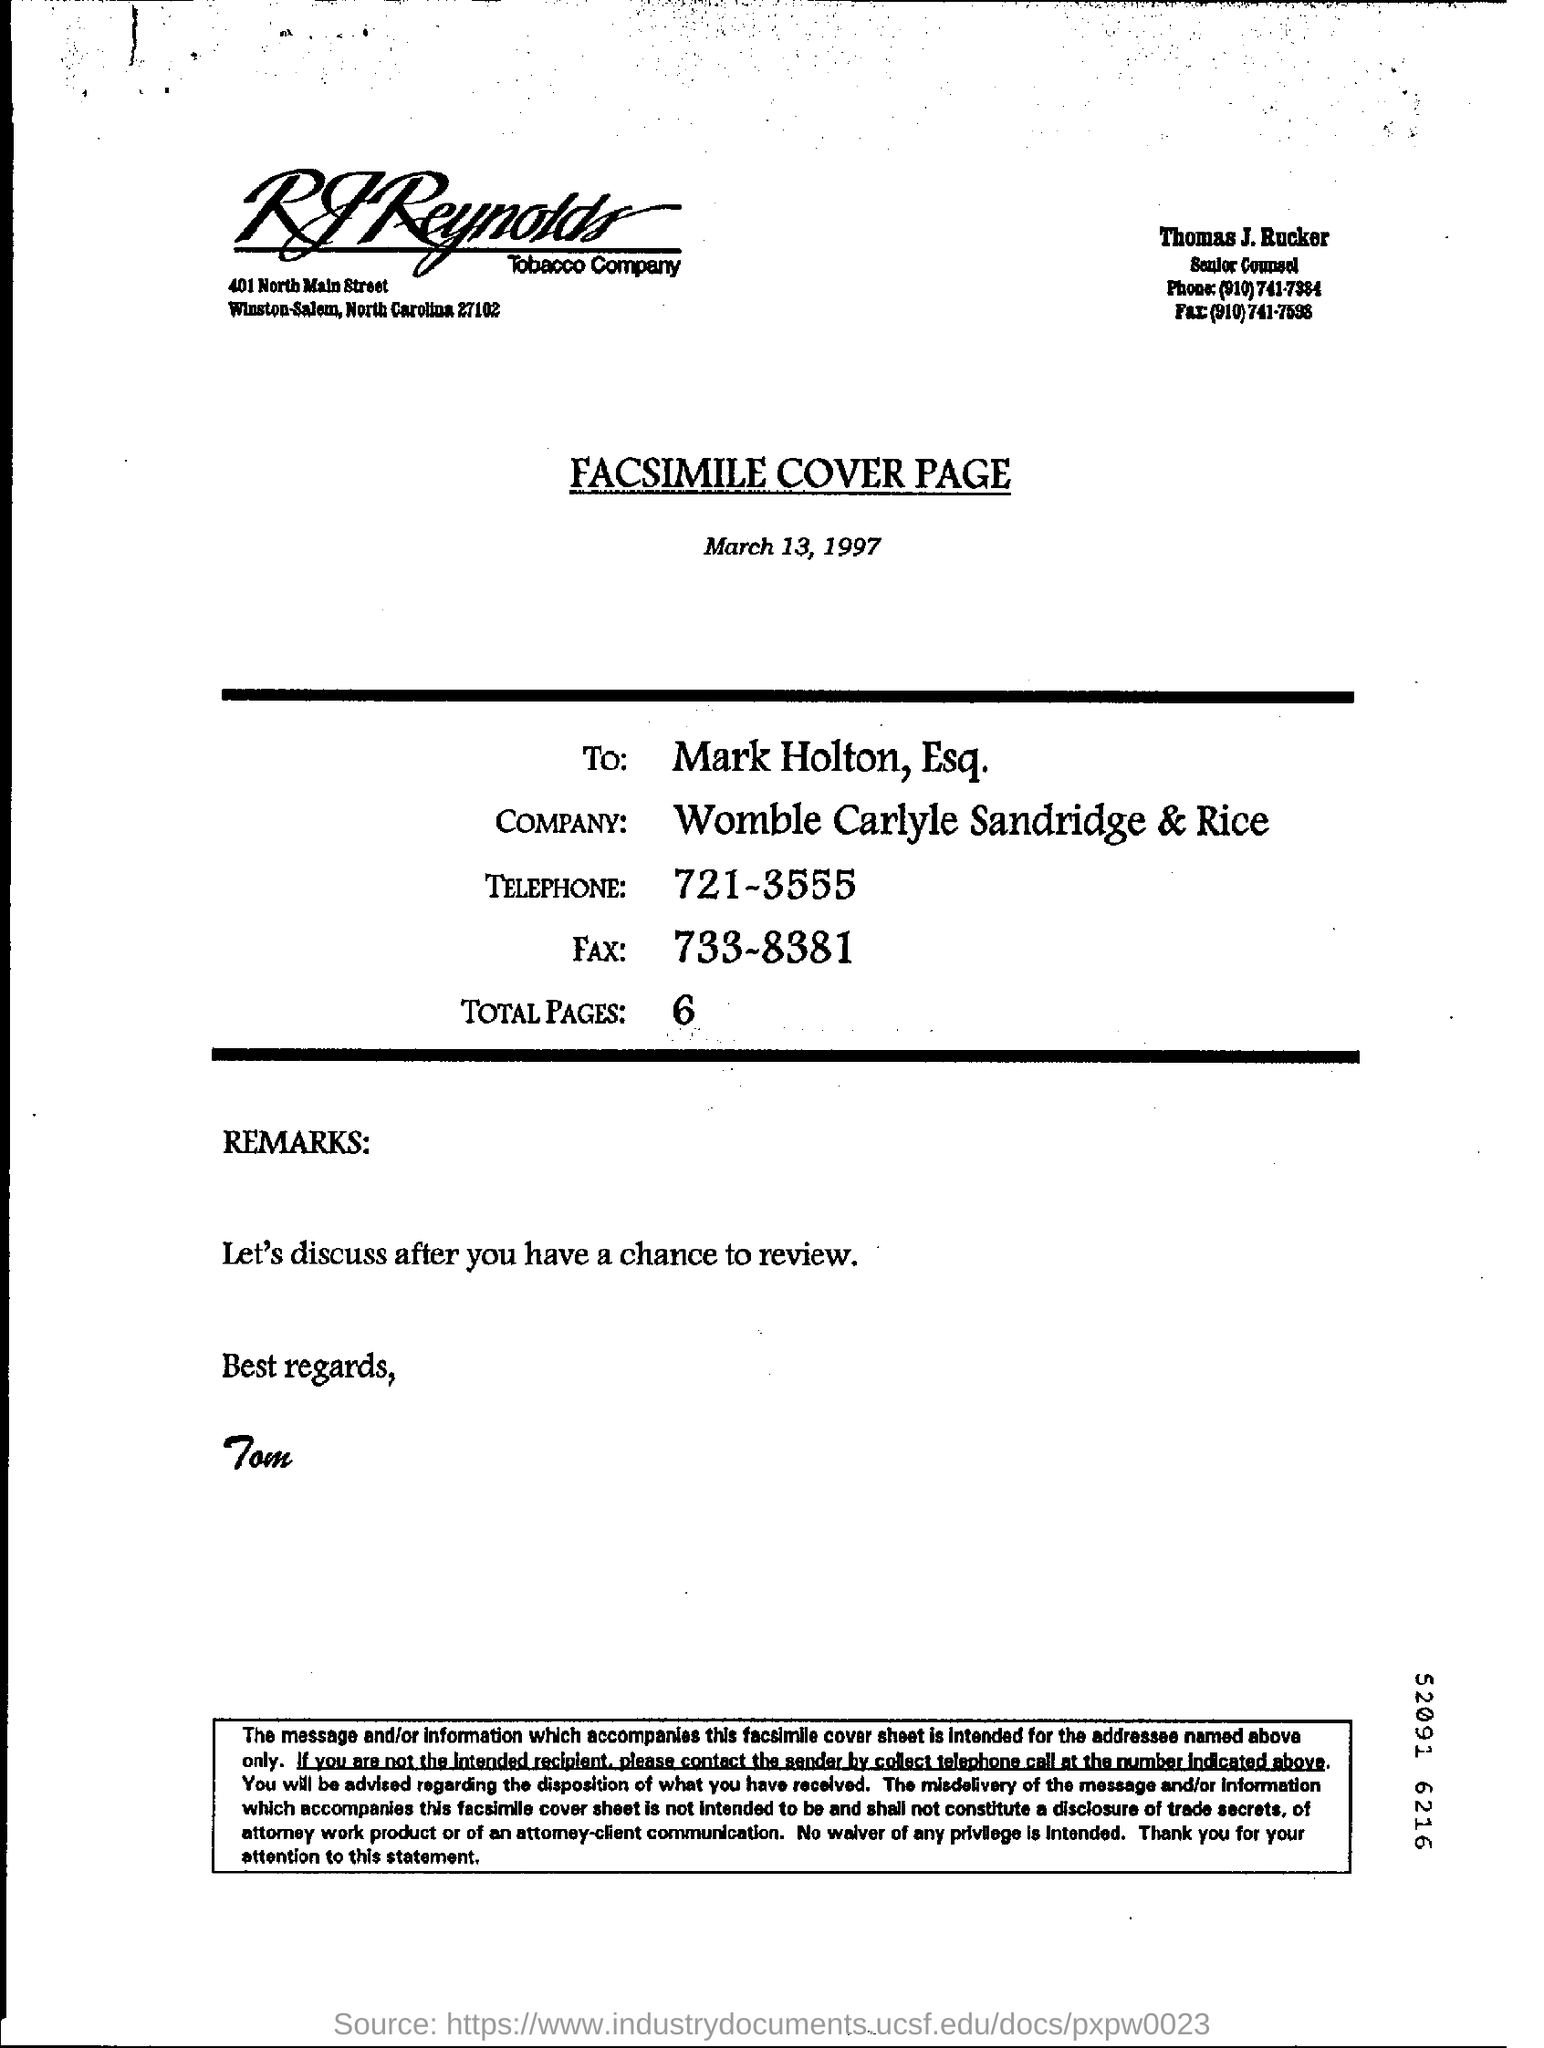Who is the facsimile to?
Give a very brief answer. Mark Holton, Esq. From whom best regards is wished?
Offer a terse response. Tom. How many pages are there totally?
Your answer should be very brief. 6. 